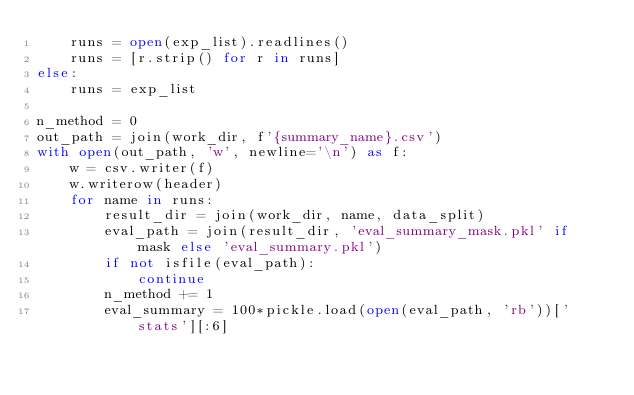Convert code to text. <code><loc_0><loc_0><loc_500><loc_500><_Python_>    runs = open(exp_list).readlines()
    runs = [r.strip() for r in runs]
else:
    runs = exp_list

n_method = 0
out_path = join(work_dir, f'{summary_name}.csv')
with open(out_path, 'w', newline='\n') as f:
    w = csv.writer(f)
    w.writerow(header)
    for name in runs:
        result_dir = join(work_dir, name, data_split)
        eval_path = join(result_dir, 'eval_summary_mask.pkl' if mask else 'eval_summary.pkl')
        if not isfile(eval_path):
            continue
        n_method += 1
        eval_summary = 100*pickle.load(open(eval_path, 'rb'))['stats'][:6]
</code> 